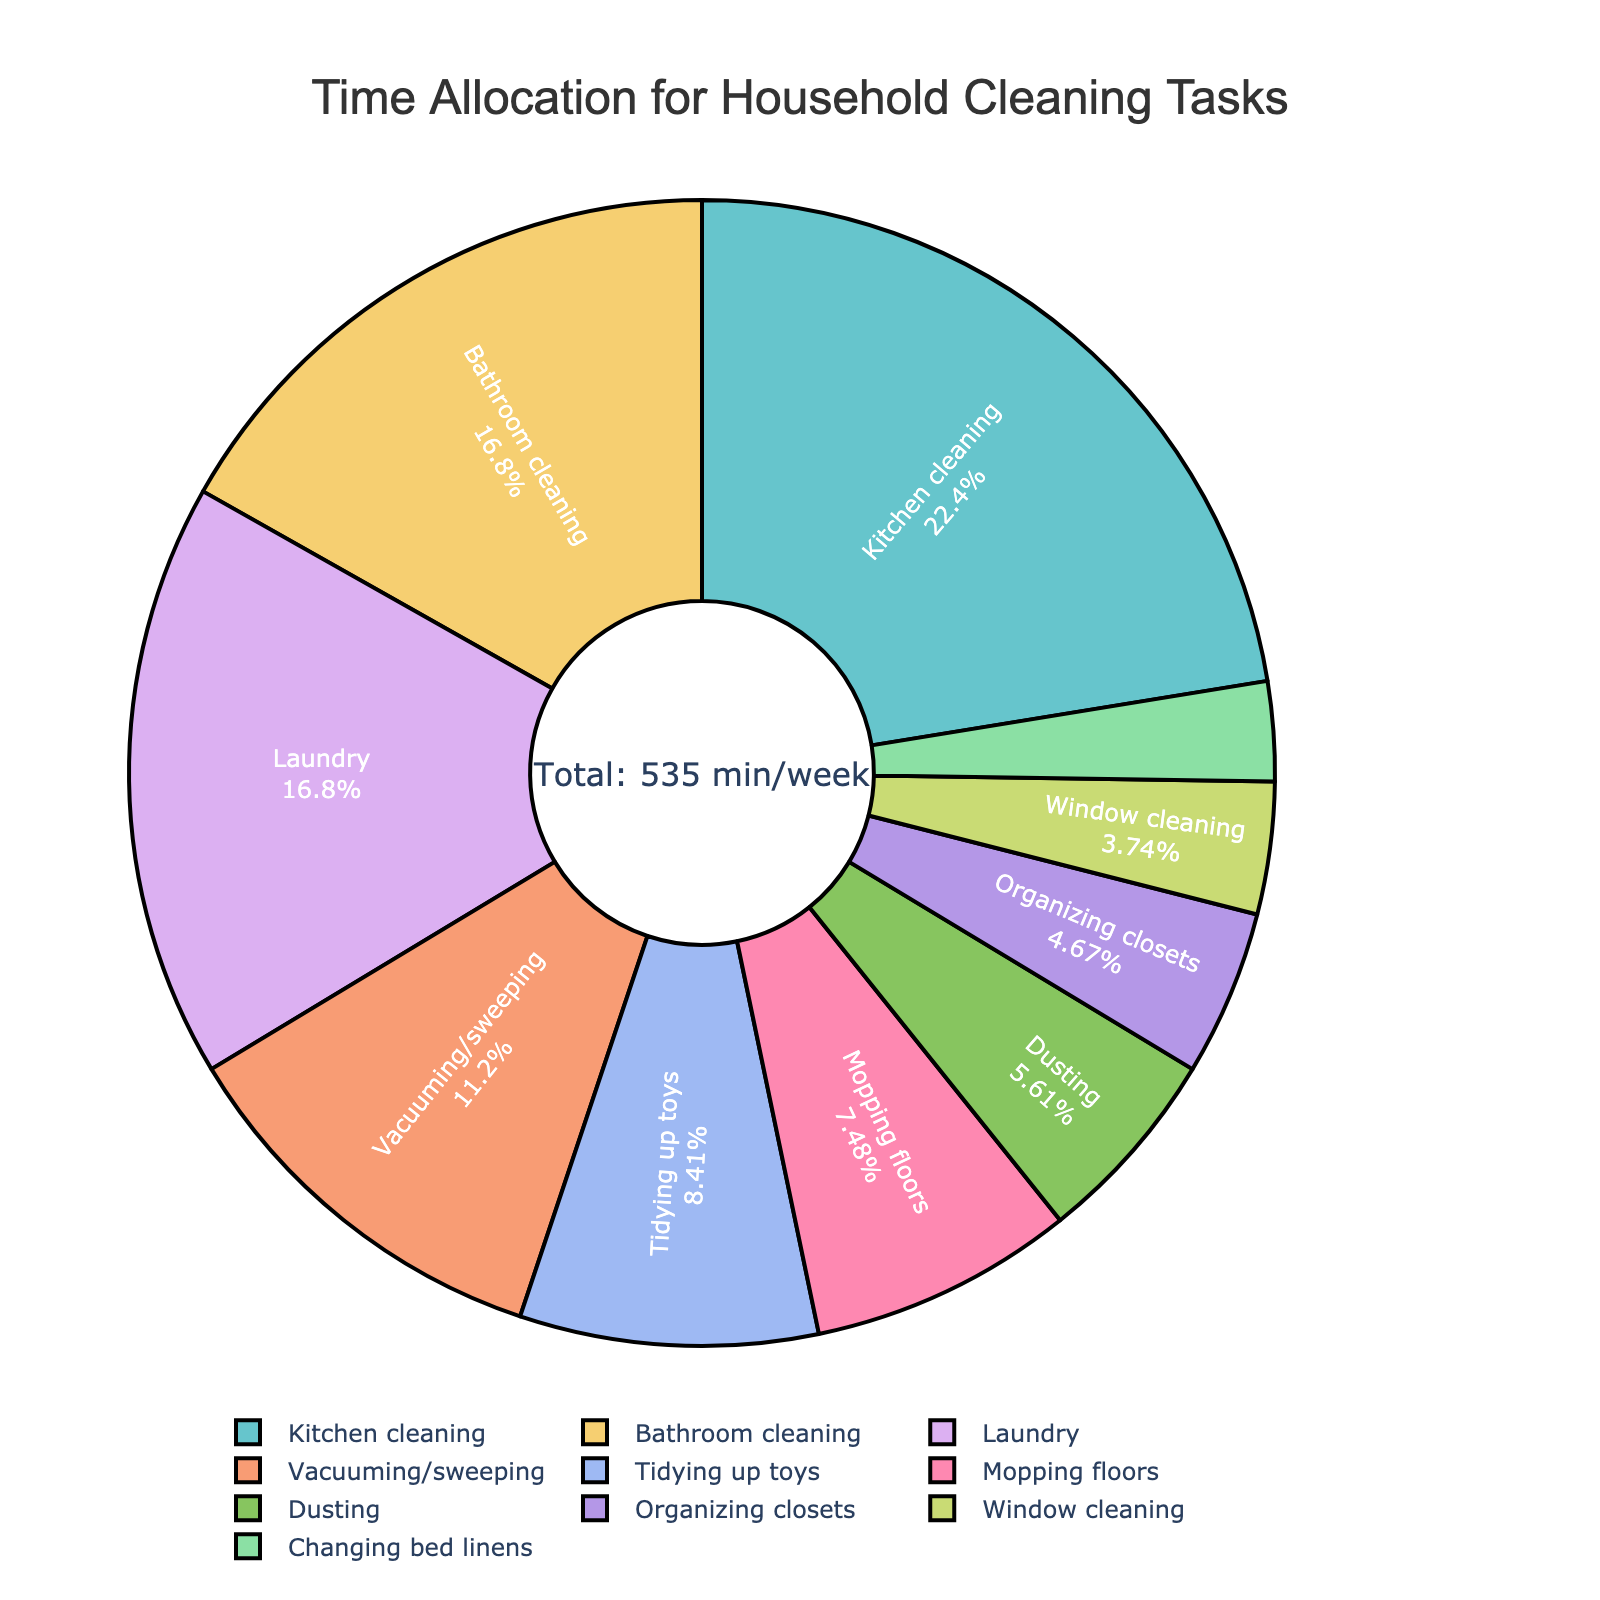Which cleaning task takes up the most time per week? The task that takes up the largest portion of the pie chart will have the largest percentage and visual area.
Answer: Kitchen cleaning How much time in total is spent on bathroom cleaning and laundry each week? Add the time spent on bathroom cleaning (90 minutes) and laundry (90 minutes): 90 + 90 = 180 minutes.
Answer: 180 minutes Which cleaning task takes up the least amount of time per week? Look for the smallest segment in the pie chart to determine the task with the smallest percentage.
Answer: Changing bed linens Is more time spent on vacuuming/sweeping or mopping floors? Compare the percentages or visual segments of vacuuming/sweeping and mopping floors on the pie chart.
Answer: Vacuuming/sweeping What is the combined percentage of time spent on tidying up toys and organizing closets? Add the percentages represented by the segments for tidying up toys and organizing closets.
Answer: (45/545)*100 + (25/545)*100 ≈ 8.3% + 4.6% = 12.9% How does the time spent on window cleaning compare to that of dusting? Check the percentages or visual sizes of the segments for window cleaning and dusting to determine which is larger.
Answer: Dusting Which two tasks together take up approximately 40% of the total cleaning time? Identify two tasks whose combined percentages add up to around 40% by examining their segments.
Answer: Kitchen cleaning (22%) and bathroom cleaning (16.5%) What is the difference in time spent between the task with the most time and the task with the least time? Subtract the time spent on the task with the least minutes (15 minutes) from the task with the most minutes (120 minutes): 120 - 15 = 105 minutes.
Answer: 105 minutes Is the time spent on kitchen cleaning more than double that of laundry? Compare the times for kitchen cleaning (120 minutes) and laundry (90 minutes). Determine if 120 is more than twice 90 (180): 120 < 180, so no.
Answer: No What percentage of the total cleaning time is devoted to mopping floors? Divide the time for mopping floors (40 minutes) by the total time (545 minutes), then multiply by 100 to get the percentage: (40/545) * 100 ≈ 7.3%.
Answer: 7.3% 